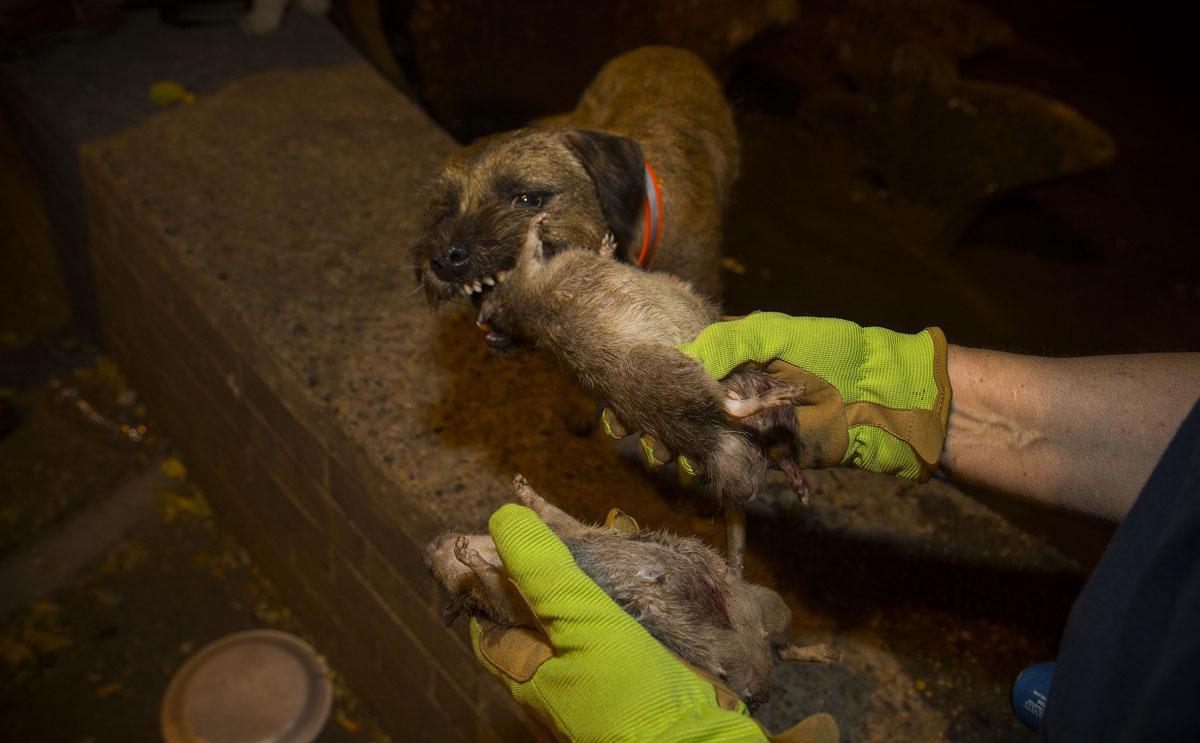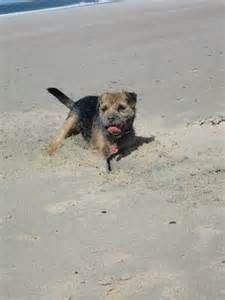The first image is the image on the left, the second image is the image on the right. Examine the images to the left and right. Is the description "There is a single dog with it's tongue slightly visible in the right image." accurate? Answer yes or no. Yes. The first image is the image on the left, the second image is the image on the right. Analyze the images presented: Is the assertion "There is a Border Terrier standing inside in the right image." valid? Answer yes or no. No. 